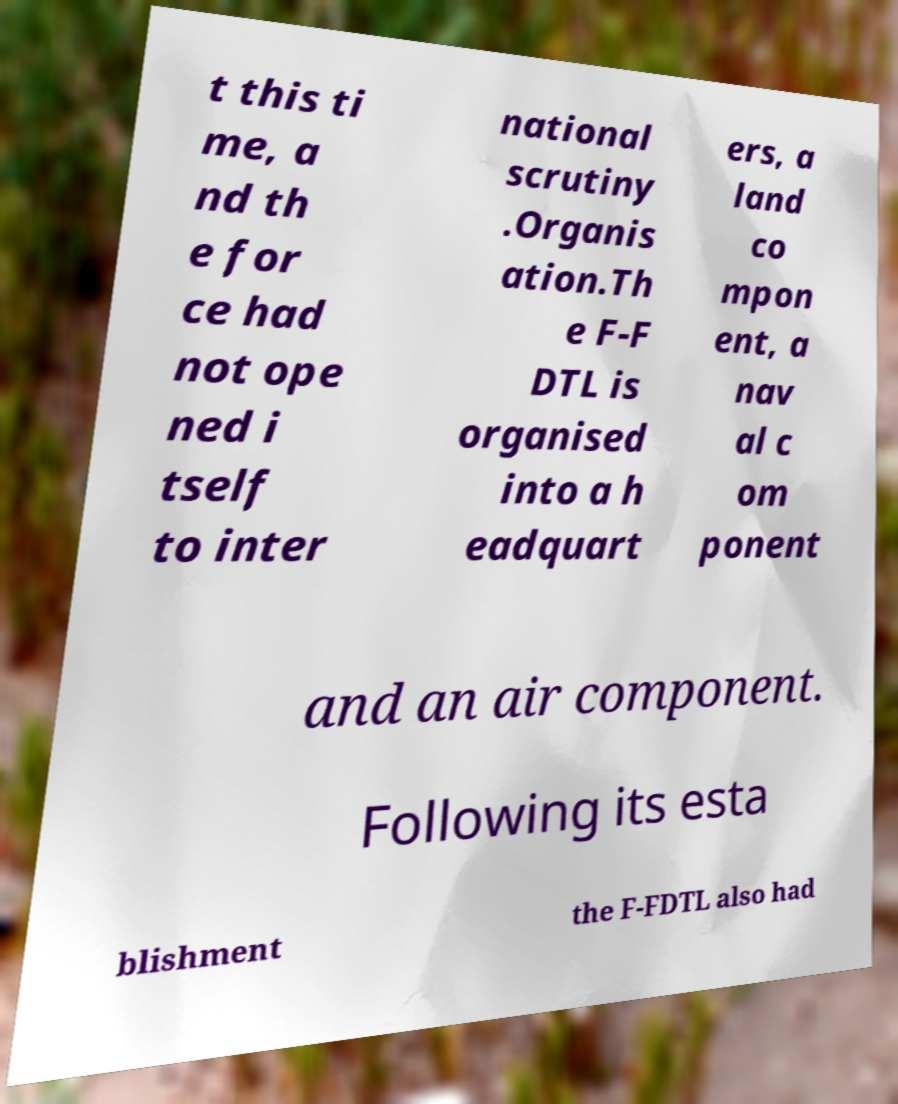There's text embedded in this image that I need extracted. Can you transcribe it verbatim? t this ti me, a nd th e for ce had not ope ned i tself to inter national scrutiny .Organis ation.Th e F-F DTL is organised into a h eadquart ers, a land co mpon ent, a nav al c om ponent and an air component. Following its esta blishment the F-FDTL also had 